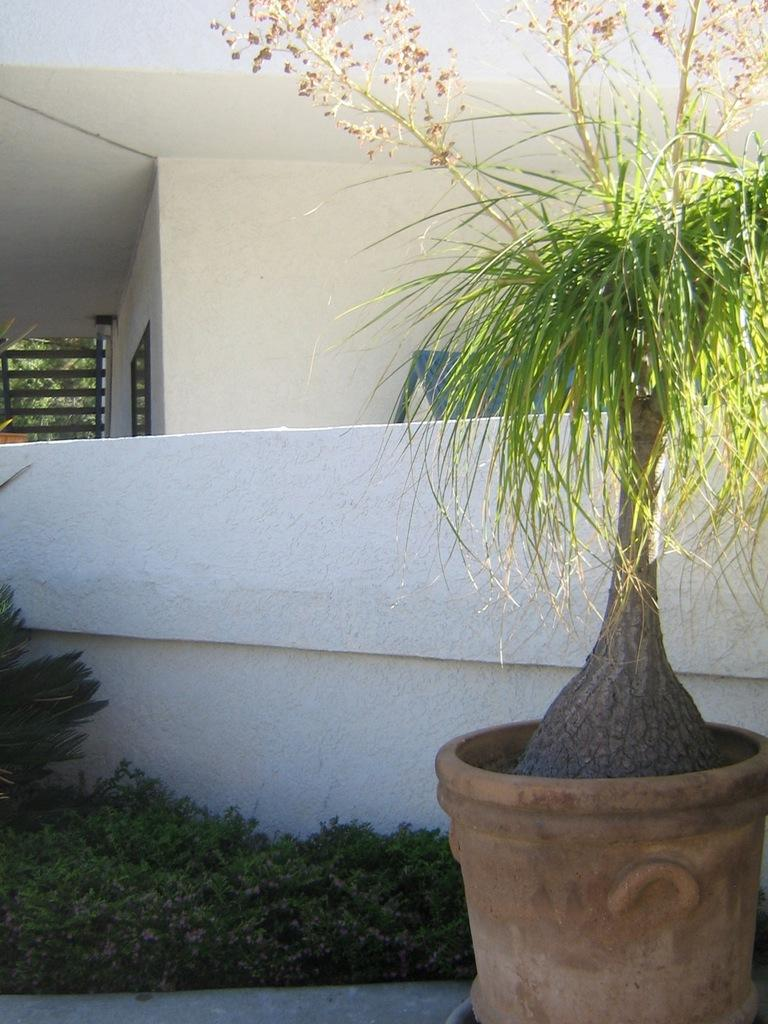What type of plant is in a pot on the right side of the image? The fact does not specify the type of plant, only that there is a plant in a pot on the right side of the image. What can be seen on the left side of the image? There are plants on the ground on the left side of the image. Where are the plants located in relation to a wall? The plants are near a wall. What can be seen in the background of the image? There is a house, trees, and objects visible in the background of the image. What language is the cow speaking in the image? There is no cow present in the image, so it is not possible to determine what language the cow might be speaking. 